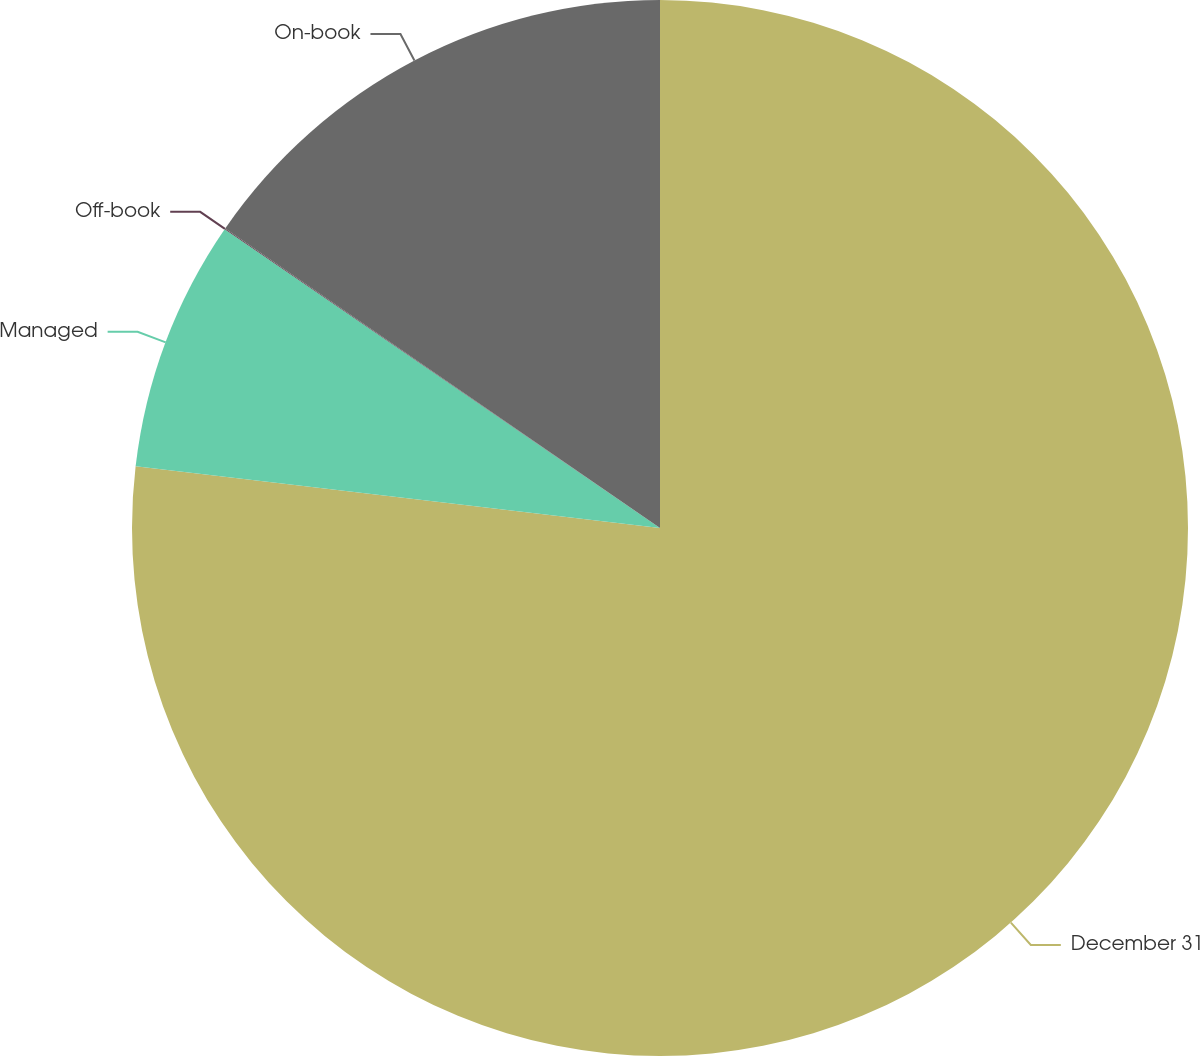Convert chart. <chart><loc_0><loc_0><loc_500><loc_500><pie_chart><fcel>December 31<fcel>Managed<fcel>Off-book<fcel>On-book<nl><fcel>76.87%<fcel>7.71%<fcel>0.03%<fcel>15.4%<nl></chart> 